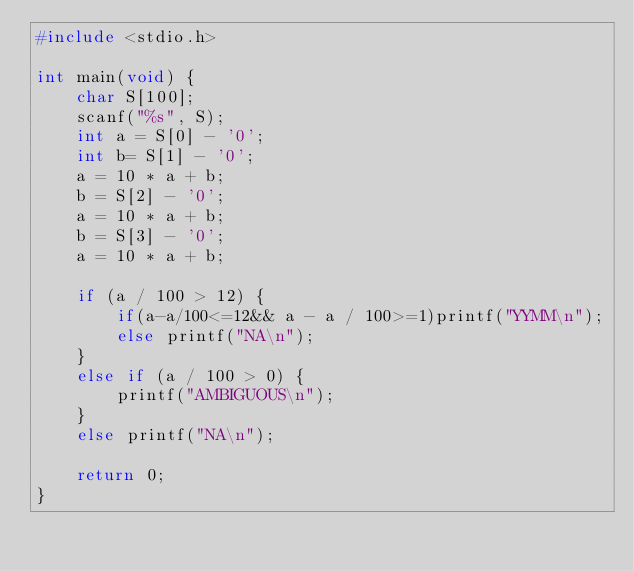Convert code to text. <code><loc_0><loc_0><loc_500><loc_500><_C_>#include <stdio.h>

int main(void) {
	char S[100];
	scanf("%s", S);
	int a = S[0] - '0';
	int b= S[1] - '0';
	a = 10 * a + b;
	b = S[2] - '0';
	a = 10 * a + b;
	b = S[3] - '0';
	a = 10 * a + b;

	if (a / 100 > 12) {
		if(a-a/100<=12&& a - a / 100>=1)printf("YYMM\n");
		else printf("NA\n");
	}
	else if (a / 100 > 0) {
		printf("AMBIGUOUS\n");
	}
	else printf("NA\n");

	return 0;
}</code> 